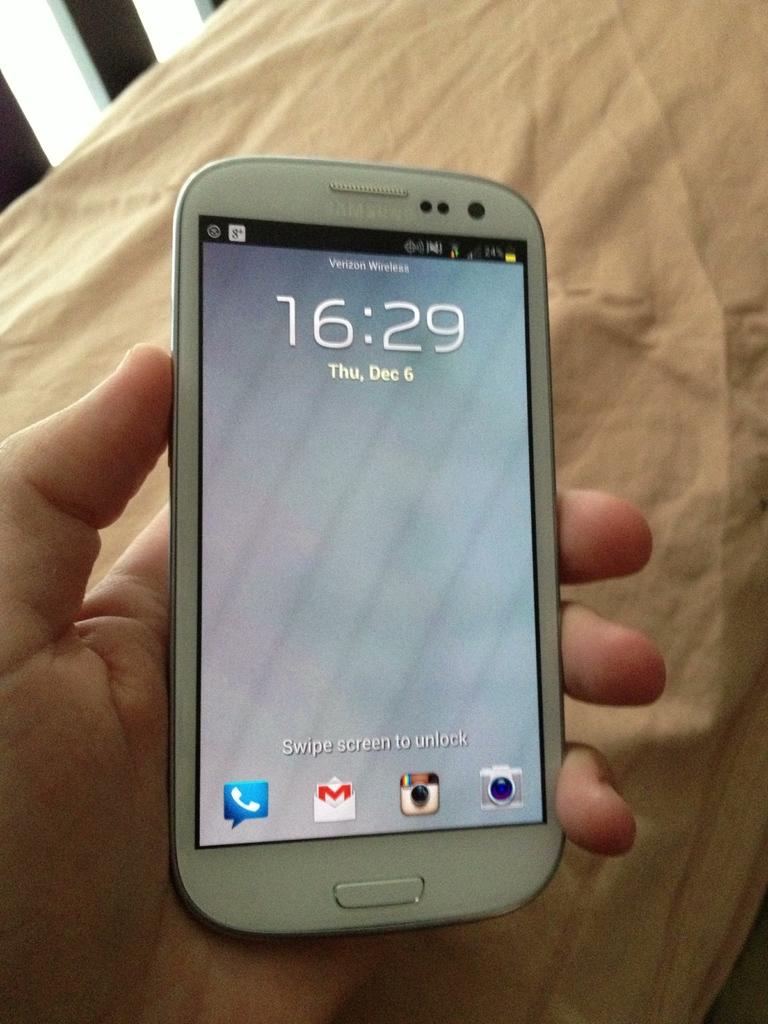What day of the week was this photo taken?
Your answer should be compact. Thursday. What is the time?
Provide a short and direct response. 16:29. 